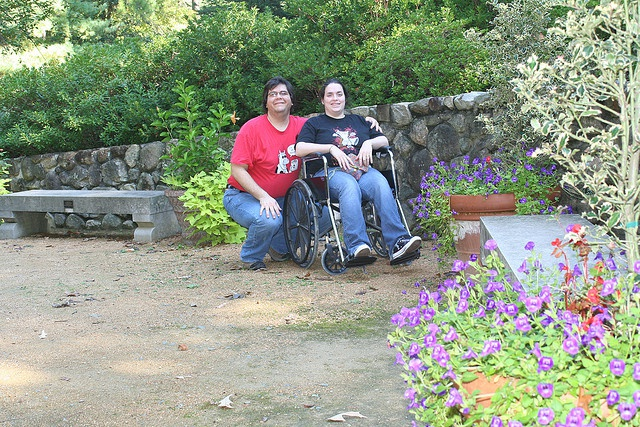Describe the objects in this image and their specific colors. I can see potted plant in khaki, lightgray, and lightgreen tones, people in khaki, lavender, gray, and darkblue tones, potted plant in khaki, gray, brown, green, and darkgreen tones, people in khaki, salmon, lavender, and gray tones, and potted plant in khaki, gray, darkgreen, and green tones in this image. 